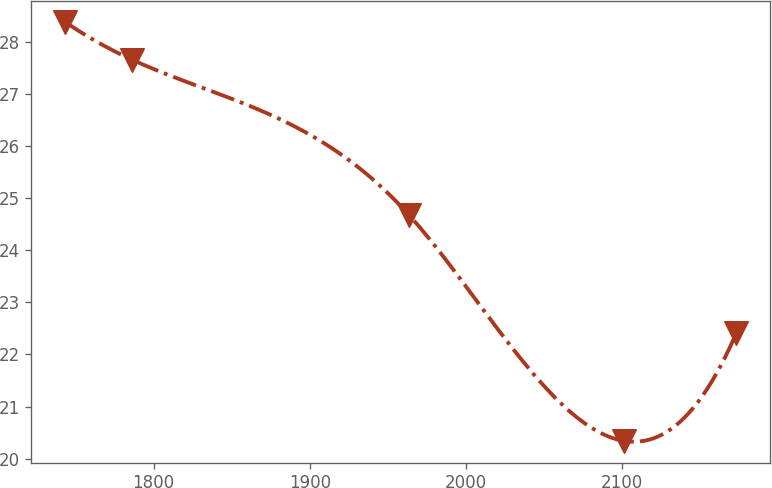<chart> <loc_0><loc_0><loc_500><loc_500><line_chart><ecel><fcel>Unnamed: 1<nl><fcel>1743.19<fcel>28.39<nl><fcel>1786.17<fcel>27.66<nl><fcel>1963.72<fcel>24.67<nl><fcel>2100.97<fcel>20.34<nl><fcel>2173<fcel>22.41<nl></chart> 